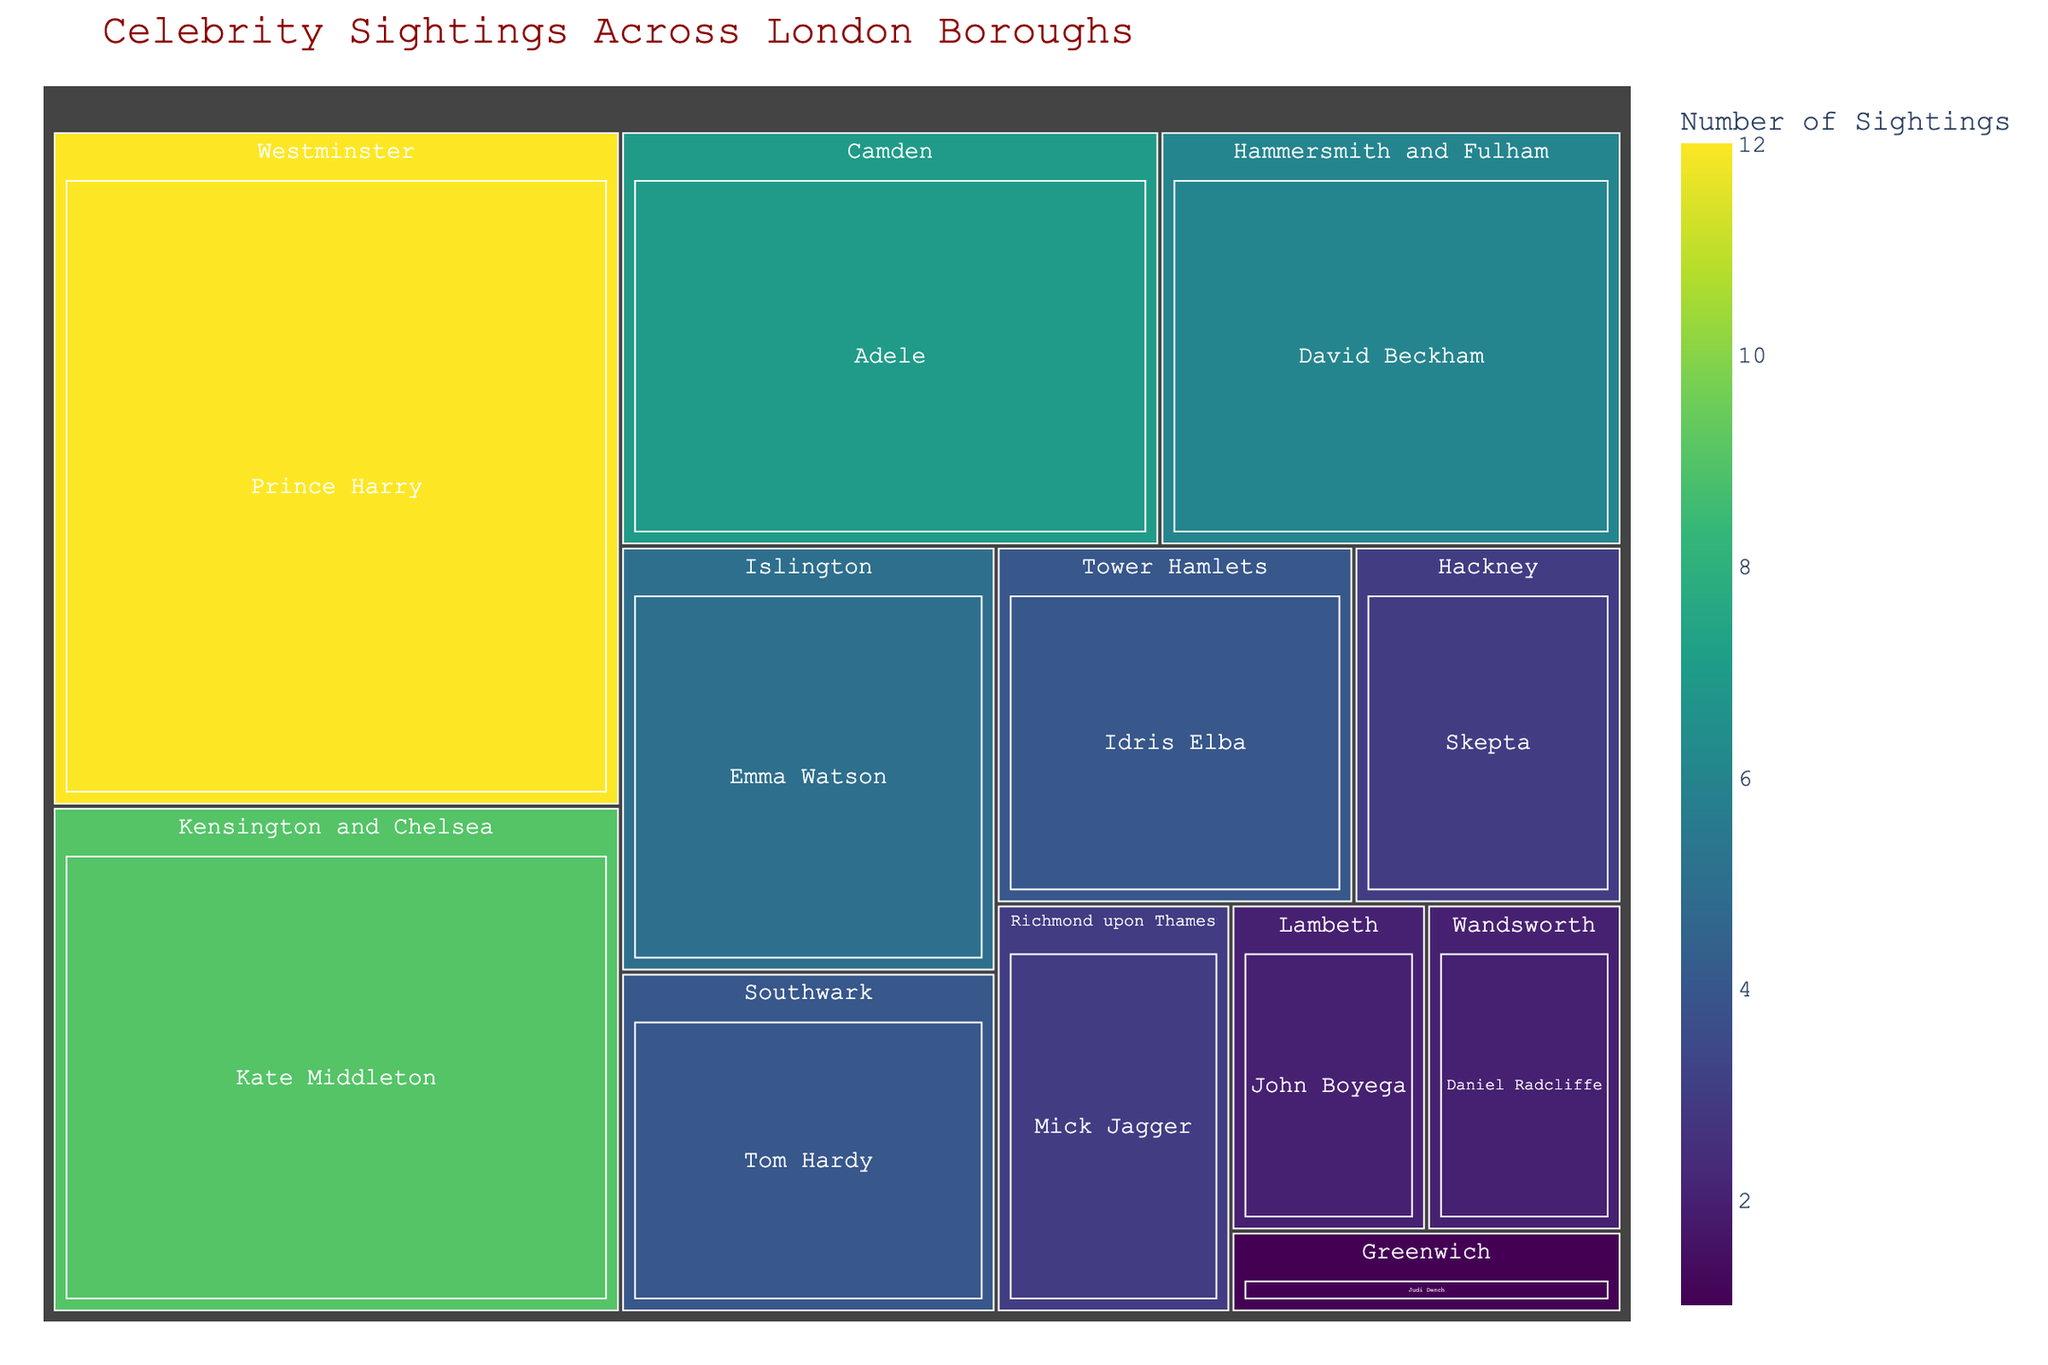Which borough has the highest number of celebrity sightings? The largest rectangle corresponds to the borough with the highest number of sightings.
Answer: Westminster How many sightings are there in Camden? Look at the size of the rectangle labeled Camden and check the value for sightings.
Answer: 7 Which two celebrities have the same number of sightings and in what boroughs? Scan through the rectangles to find any with identical sizes and sighting values.
Answer: Idris Elba in Tower Hamlets and Tom Hardy in Southwark, both have 4 sightings Which boroughs have exactly 2 celebrity sightings? Check the rectangles labeled with "2" sightings.
Answer: Wandsworth and Lambeth What’s the total number of celebrity sightings across all boroughs? Add up the sightings from all rectangles: 12 (Westminster) + 9 (Kensington and Chelsea) + 7 (Camden) + 6 (Hammersmith and Fulham) + 5 (Islington) + 4 (Tower Hamlets) + 4 (Southwark) + 3 (Hackney) + 3 (Richmond upon Thames) + 2 (Wandsworth) + 2 (Lambeth) + 1 (Greenwich).
Answer: 58 Is there any borough with more celebrity sightings than Kensington and Chelsea but less than Westminster? Compare the values: Kensington and Chelsea has 9, and Westminster has 12.
Answer: No What's the average number of sightings per borough? Calculate the average by dividing the total number of sightings (58) by the number of boroughs (12). 58 / 12 = 4.83.
Answer: 4.83 Which borough has sightings of Emma Watson, and how many are there? Find the rectangle for Emma Watson and note the corresponding borough and number of sightings.
Answer: Islington, 5 Between David Beckham in Hammersmith and Fulham and Mick Jagger in Richmond upon Thames, who has more sightings? Compare the sighting values: David Beckham with 6, Mick Jagger with 3.
Answer: David Beckham Are there more celebrity sightings in the boroughs located west of the Thames River compared to those east of the river? Sum up and compare sightings from boroughs west (like Westminster, Kensington and Chelsea, etc.) versus those east (like Tower Hamlets, Greenwich). Examples of west: 12 + 9 + 6 + 3 + 2. Examples of east: 4 + 1.
Answer: Yes 